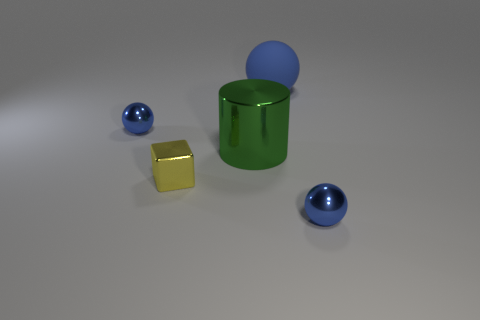Add 3 big metal objects. How many objects exist? 8 Subtract all balls. How many objects are left? 2 Add 3 big matte things. How many big matte things exist? 4 Subtract 0 blue cylinders. How many objects are left? 5 Subtract all tiny blue objects. Subtract all big metal objects. How many objects are left? 2 Add 4 blue matte balls. How many blue matte balls are left? 5 